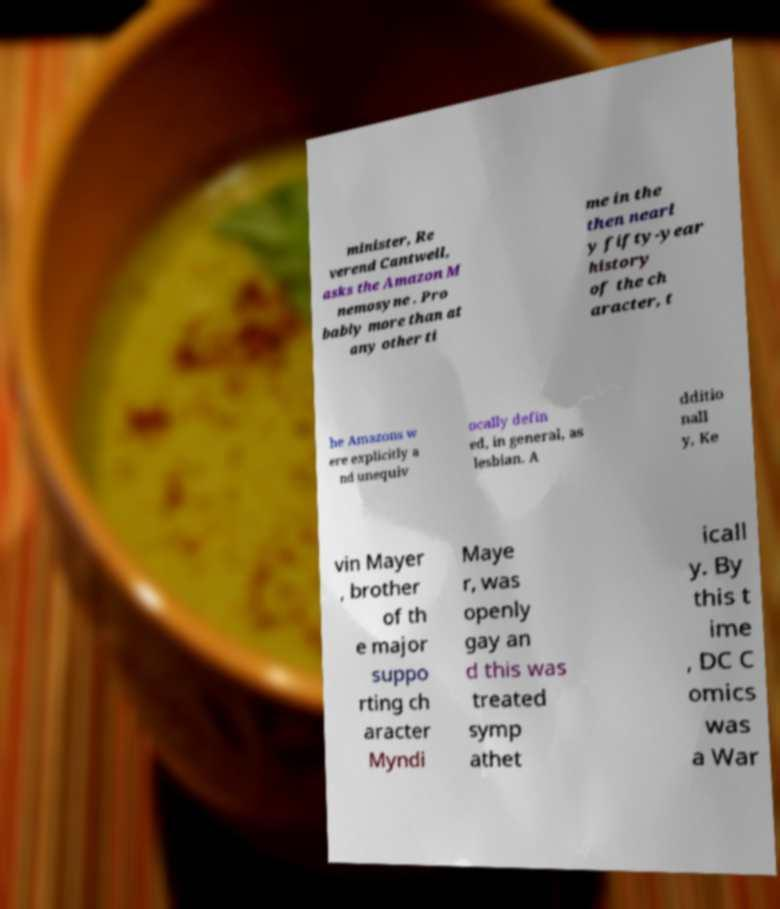Could you extract and type out the text from this image? minister, Re verend Cantwell, asks the Amazon M nemosyne . Pro bably more than at any other ti me in the then nearl y fifty-year history of the ch aracter, t he Amazons w ere explicitly a nd unequiv ocally defin ed, in general, as lesbian. A dditio nall y, Ke vin Mayer , brother of th e major suppo rting ch aracter Myndi Maye r, was openly gay an d this was treated symp athet icall y. By this t ime , DC C omics was a War 